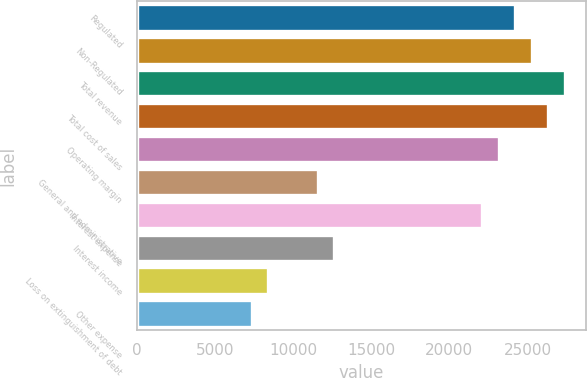Convert chart to OTSL. <chart><loc_0><loc_0><loc_500><loc_500><bar_chart><fcel>Regulated<fcel>Non-Regulated<fcel>Total revenue<fcel>Total cost of sales<fcel>Operating margin<fcel>General and administrative<fcel>Interest expense<fcel>Interest income<fcel>Loss on extinguishment of debt<fcel>Other expense<nl><fcel>24218.3<fcel>25271.3<fcel>27377.2<fcel>26324.2<fcel>23165.4<fcel>11582.9<fcel>22112.4<fcel>12635.9<fcel>8424.09<fcel>7371.14<nl></chart> 